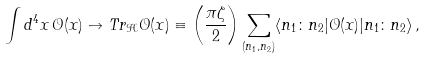Convert formula to latex. <formula><loc_0><loc_0><loc_500><loc_500>\int d ^ { 4 } x \, \mathcal { O } ( x ) \to T r _ { \mathcal { H } } \mathcal { O } ( x ) \equiv \left ( \frac { \pi \zeta } { 2 } \right ) \sum _ { ( n _ { 1 } , n _ { 2 } ) } \langle n _ { 1 } \colon n _ { 2 } | \mathcal { O } ( x ) | n _ { 1 } \colon n _ { 2 } \rangle \, ,</formula> 